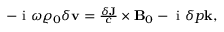<formula> <loc_0><loc_0><loc_500><loc_500>\begin{array} { r } { - i \omega \varrho _ { 0 } \delta v = \frac { \delta J } { c } \times B _ { 0 } - i \delta p k , } \end{array}</formula> 